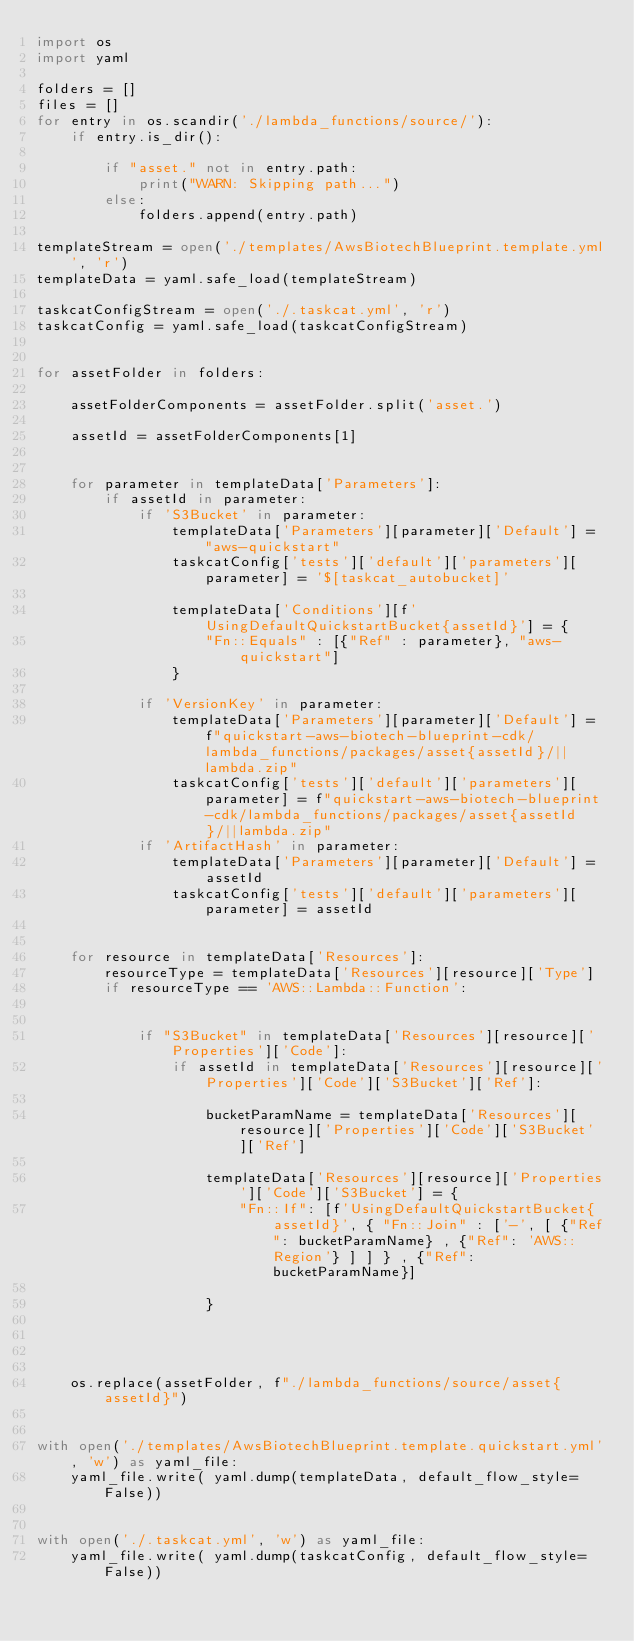Convert code to text. <code><loc_0><loc_0><loc_500><loc_500><_Python_>import os
import yaml 

folders = []
files = []
for entry in os.scandir('./lambda_functions/source/'):
    if entry.is_dir():

        if "asset." not in entry.path:
            print("WARN: Skipping path...")
        else:
            folders.append(entry.path)

templateStream = open('./templates/AwsBiotechBlueprint.template.yml', 'r')
templateData = yaml.safe_load(templateStream)

taskcatConfigStream = open('./.taskcat.yml', 'r')
taskcatConfig = yaml.safe_load(taskcatConfigStream)


for assetFolder in folders:
    
    assetFolderComponents = assetFolder.split('asset.')
    
    assetId = assetFolderComponents[1]
    

    for parameter in templateData['Parameters']:
        if assetId in parameter:
            if 'S3Bucket' in parameter:
                templateData['Parameters'][parameter]['Default'] = "aws-quickstart"
                taskcatConfig['tests']['default']['parameters'][parameter] = '$[taskcat_autobucket]'
                
                templateData['Conditions'][f'UsingDefaultQuickstartBucket{assetId}'] = {
                    "Fn::Equals" : [{"Ref" : parameter}, "aws-quickstart"]
                }
                
            if 'VersionKey' in parameter:
                templateData['Parameters'][parameter]['Default'] = f"quickstart-aws-biotech-blueprint-cdk/lambda_functions/packages/asset{assetId}/||lambda.zip"
                taskcatConfig['tests']['default']['parameters'][parameter] = f"quickstart-aws-biotech-blueprint-cdk/lambda_functions/packages/asset{assetId}/||lambda.zip"
            if 'ArtifactHash' in parameter:
                templateData['Parameters'][parameter]['Default'] = assetId
                taskcatConfig['tests']['default']['parameters'][parameter] = assetId
            
    
    for resource in templateData['Resources']:
        resourceType = templateData['Resources'][resource]['Type']
        if resourceType == 'AWS::Lambda::Function':
            
            
            if "S3Bucket" in templateData['Resources'][resource]['Properties']['Code']:
                if assetId in templateData['Resources'][resource]['Properties']['Code']['S3Bucket']['Ref']:
                    
                    bucketParamName = templateData['Resources'][resource]['Properties']['Code']['S3Bucket']['Ref']
                    
                    templateData['Resources'][resource]['Properties']['Code']['S3Bucket'] = {
                        "Fn::If": [f'UsingDefaultQuickstartBucket{assetId}', { "Fn::Join" : ['-', [ {"Ref": bucketParamName} , {"Ref": 'AWS::Region'} ] ] } , {"Ref": bucketParamName}]
                        
                    }
                    

   
    
    os.replace(assetFolder, f"./lambda_functions/source/asset{assetId}")

    
with open('./templates/AwsBiotechBlueprint.template.quickstart.yml', 'w') as yaml_file:
    yaml_file.write( yaml.dump(templateData, default_flow_style=False))
    

with open('./.taskcat.yml', 'w') as yaml_file:
    yaml_file.write( yaml.dump(taskcatConfig, default_flow_style=False))</code> 